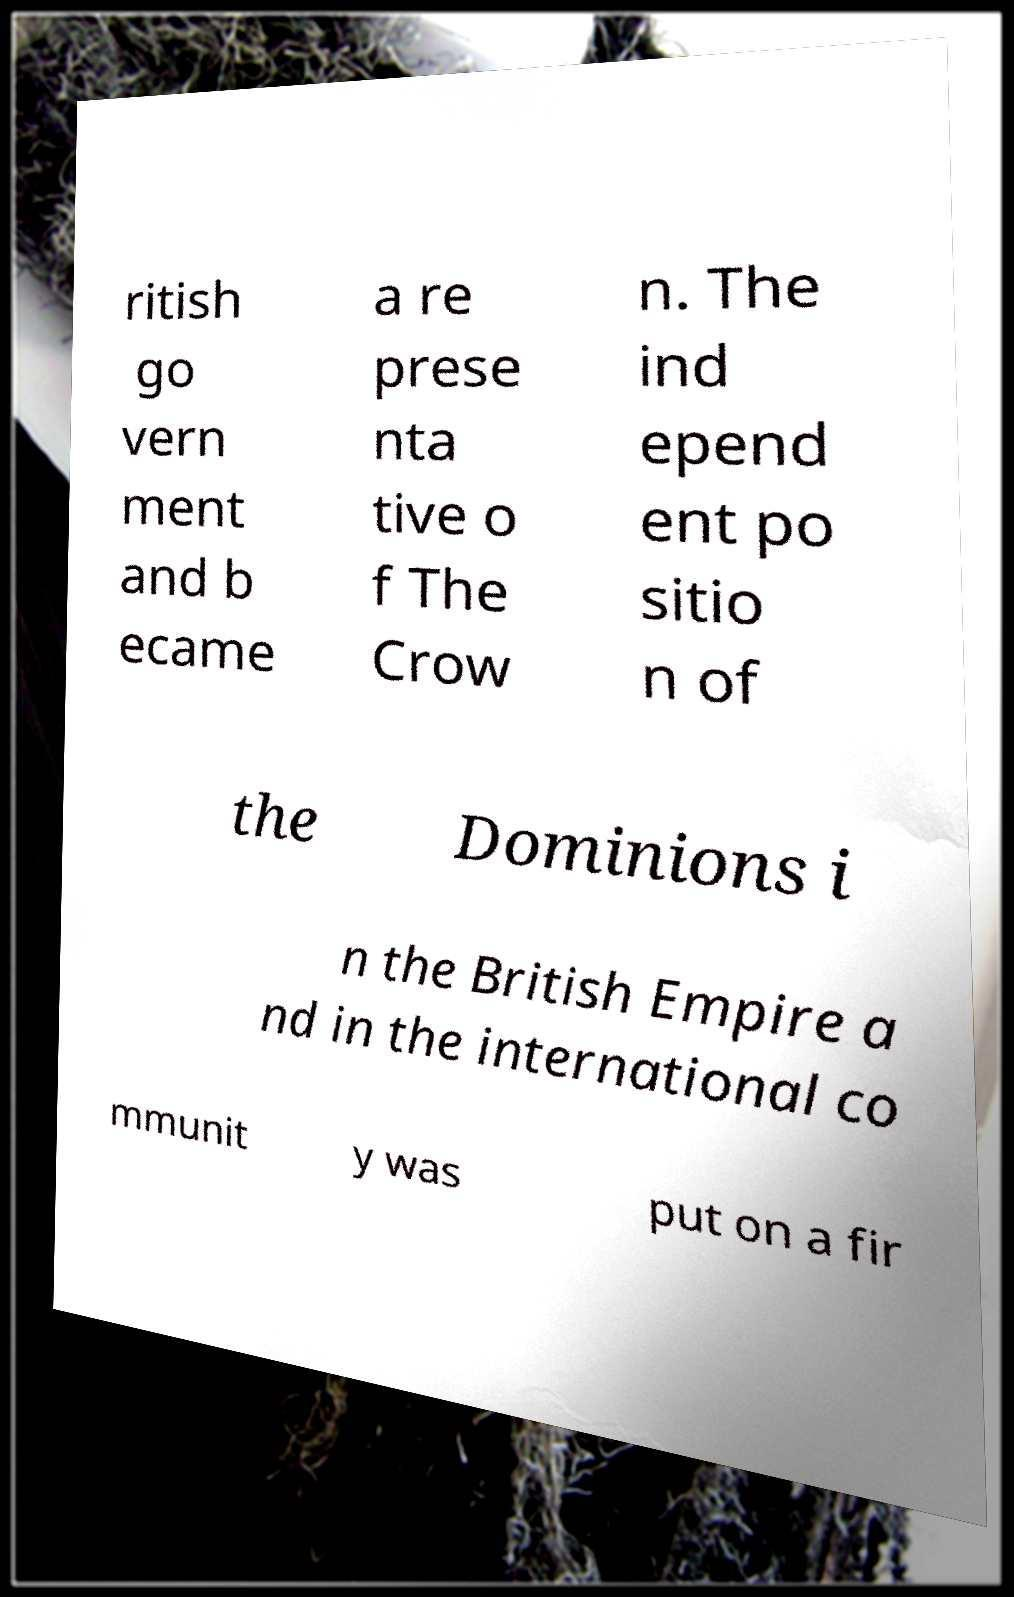What messages or text are displayed in this image? I need them in a readable, typed format. ritish go vern ment and b ecame a re prese nta tive o f The Crow n. The ind epend ent po sitio n of the Dominions i n the British Empire a nd in the international co mmunit y was put on a fir 